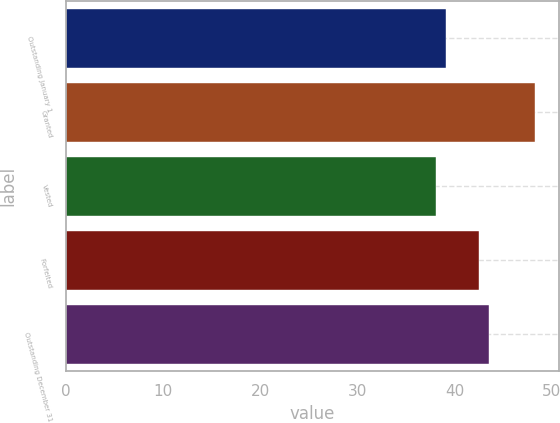<chart> <loc_0><loc_0><loc_500><loc_500><bar_chart><fcel>Outstanding January 1<fcel>Granted<fcel>Vested<fcel>Forfeited<fcel>Outstanding December 31<nl><fcel>39.11<fcel>48.29<fcel>38.09<fcel>42.56<fcel>43.58<nl></chart> 